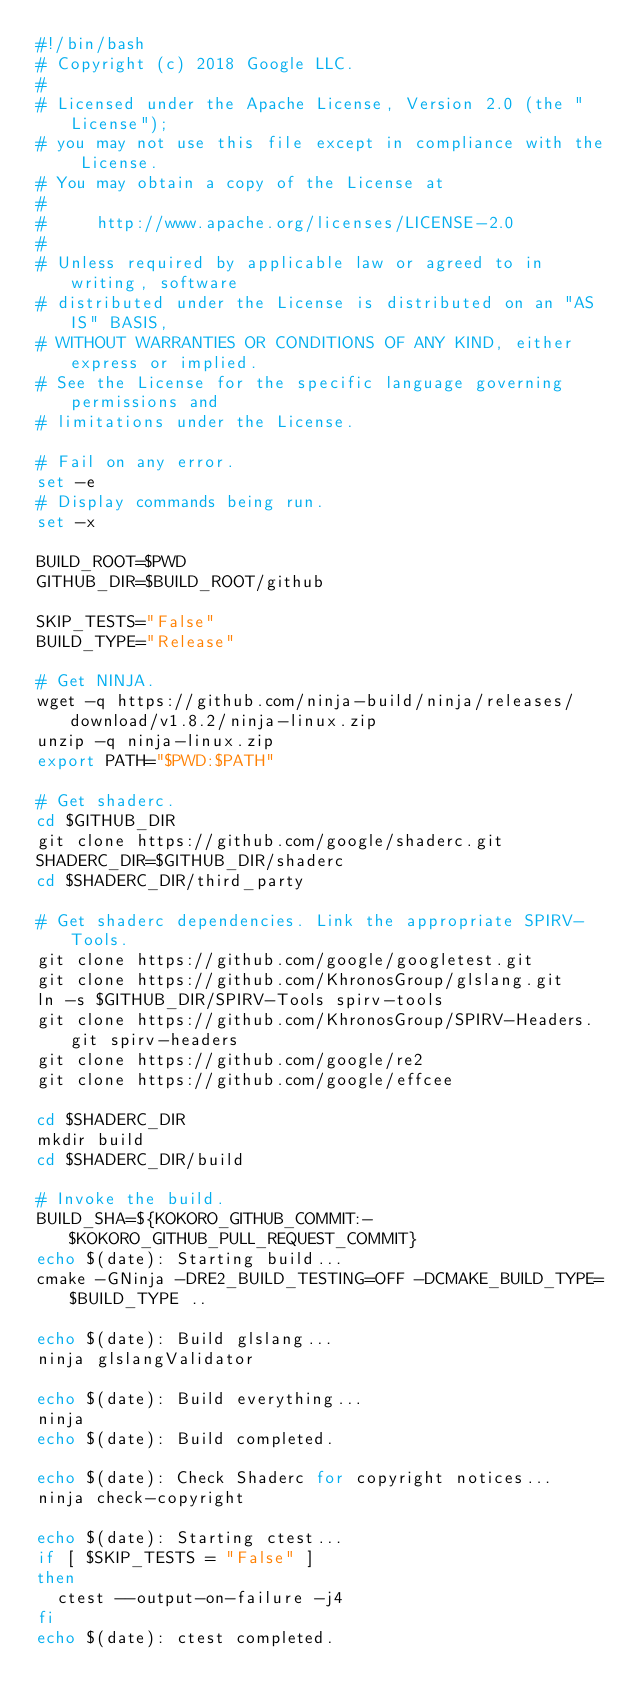<code> <loc_0><loc_0><loc_500><loc_500><_Bash_>#!/bin/bash
# Copyright (c) 2018 Google LLC.
#
# Licensed under the Apache License, Version 2.0 (the "License");
# you may not use this file except in compliance with the License.
# You may obtain a copy of the License at
#
#     http://www.apache.org/licenses/LICENSE-2.0
#
# Unless required by applicable law or agreed to in writing, software
# distributed under the License is distributed on an "AS IS" BASIS,
# WITHOUT WARRANTIES OR CONDITIONS OF ANY KIND, either express or implied.
# See the License for the specific language governing permissions and
# limitations under the License.

# Fail on any error.
set -e
# Display commands being run.
set -x

BUILD_ROOT=$PWD
GITHUB_DIR=$BUILD_ROOT/github

SKIP_TESTS="False"
BUILD_TYPE="Release"

# Get NINJA.
wget -q https://github.com/ninja-build/ninja/releases/download/v1.8.2/ninja-linux.zip
unzip -q ninja-linux.zip
export PATH="$PWD:$PATH"

# Get shaderc.
cd $GITHUB_DIR
git clone https://github.com/google/shaderc.git
SHADERC_DIR=$GITHUB_DIR/shaderc
cd $SHADERC_DIR/third_party

# Get shaderc dependencies. Link the appropriate SPIRV-Tools.
git clone https://github.com/google/googletest.git
git clone https://github.com/KhronosGroup/glslang.git
ln -s $GITHUB_DIR/SPIRV-Tools spirv-tools
git clone https://github.com/KhronosGroup/SPIRV-Headers.git spirv-headers
git clone https://github.com/google/re2
git clone https://github.com/google/effcee

cd $SHADERC_DIR
mkdir build
cd $SHADERC_DIR/build

# Invoke the build.
BUILD_SHA=${KOKORO_GITHUB_COMMIT:-$KOKORO_GITHUB_PULL_REQUEST_COMMIT}
echo $(date): Starting build...
cmake -GNinja -DRE2_BUILD_TESTING=OFF -DCMAKE_BUILD_TYPE=$BUILD_TYPE ..

echo $(date): Build glslang...
ninja glslangValidator

echo $(date): Build everything...
ninja
echo $(date): Build completed.

echo $(date): Check Shaderc for copyright notices...
ninja check-copyright

echo $(date): Starting ctest...
if [ $SKIP_TESTS = "False" ]
then
  ctest --output-on-failure -j4
fi
echo $(date): ctest completed.

</code> 